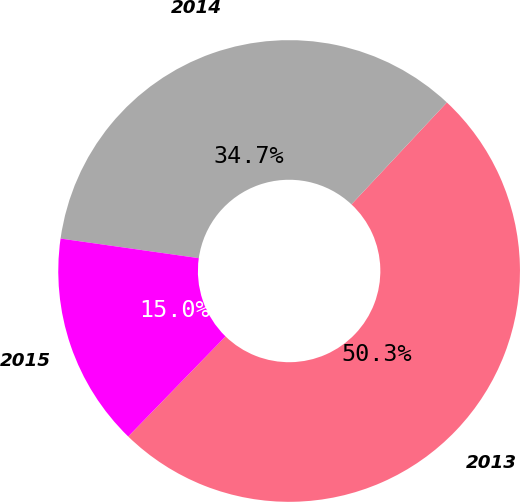<chart> <loc_0><loc_0><loc_500><loc_500><pie_chart><fcel>2013<fcel>2014<fcel>2015<nl><fcel>50.3%<fcel>34.73%<fcel>14.97%<nl></chart> 